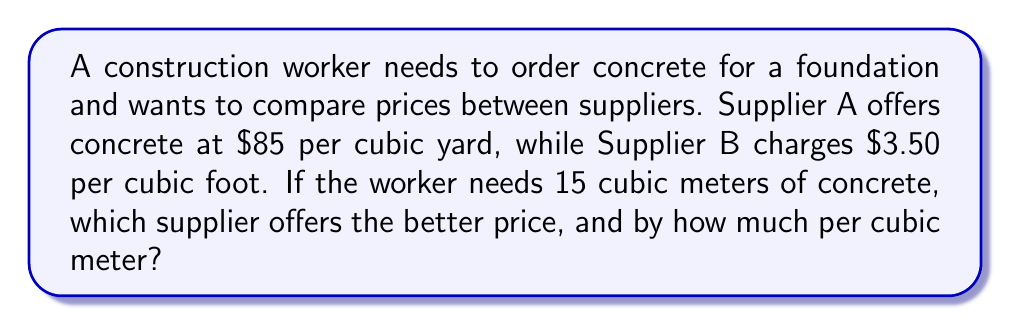What is the answer to this math problem? To solve this problem, we need to convert all measurements to the same unit (cubic meters) and calculate the price per cubic meter for each supplier.

Step 1: Convert cubic yards to cubic meters (Supplier A)
1 cubic yard ≈ 0.764555 cubic meters
$85 per cubic yard = $85 ÷ 0.764555 ≈ $111.17 per cubic meter

Step 2: Convert cubic feet to cubic meters (Supplier B)
1 cubic foot ≈ 0.0283168 cubic meters
$3.50 per cubic foot = $3.50 ÷ 0.0283168 ≈ $123.60 per cubic meter

Step 3: Calculate the price difference per cubic meter
$123.60 - $111.17 = $12.43 per cubic meter

Step 4: Determine which supplier is cheaper
Supplier A is cheaper by $12.43 per cubic meter.

Step 5: Calculate the total savings for 15 cubic meters
$12.43 × 15 = $186.45

Therefore, Supplier A offers the better price, saving $12.43 per cubic meter or $186.45 for the entire 15 cubic meter order.
Answer: Supplier A; $12.43/m³ 